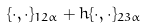<formula> <loc_0><loc_0><loc_500><loc_500>\{ \cdot , \cdot \} _ { 1 2 \alpha } + h \{ \cdot , \cdot \} _ { 2 3 \alpha }</formula> 